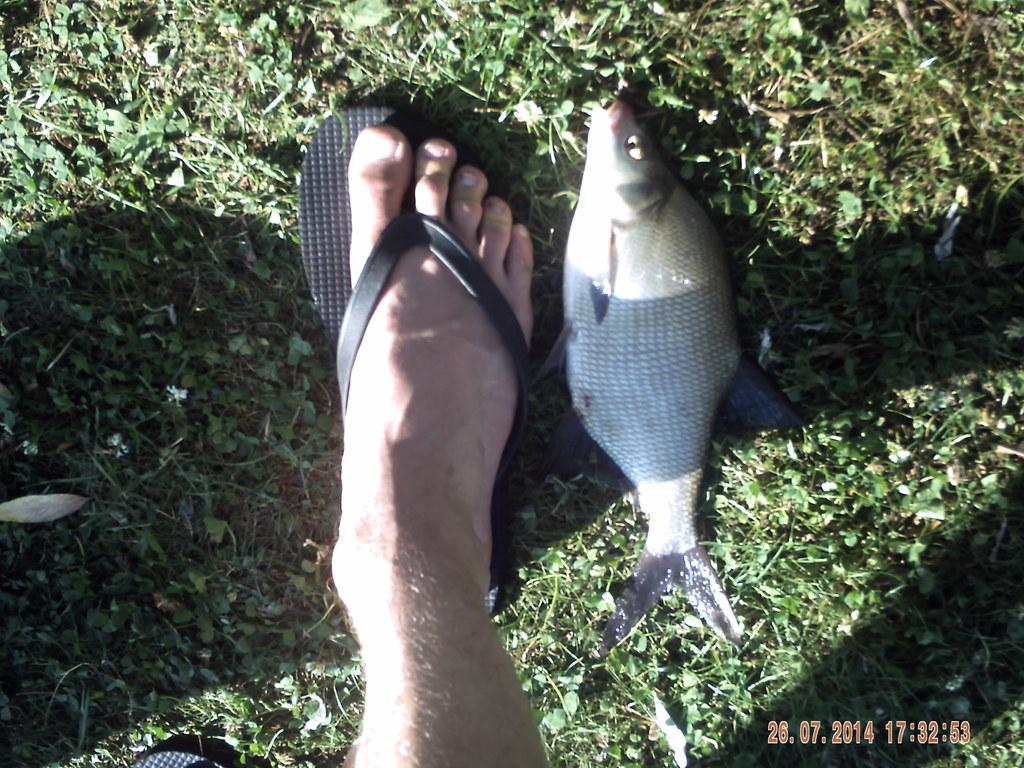What part of a person can be seen in the image? There is a person's leg in the image. What type of animal is visible on the grass? There is a fish visible on the grass. What type of footwear is visible on the grass? There is a sandal visible on the grass. What can be read at the bottom of the image? There is text visible at the bottom of the image. How many babies are paying attention to the fish in the image? There are no babies present in the image, and therefore no such interaction can be observed. 